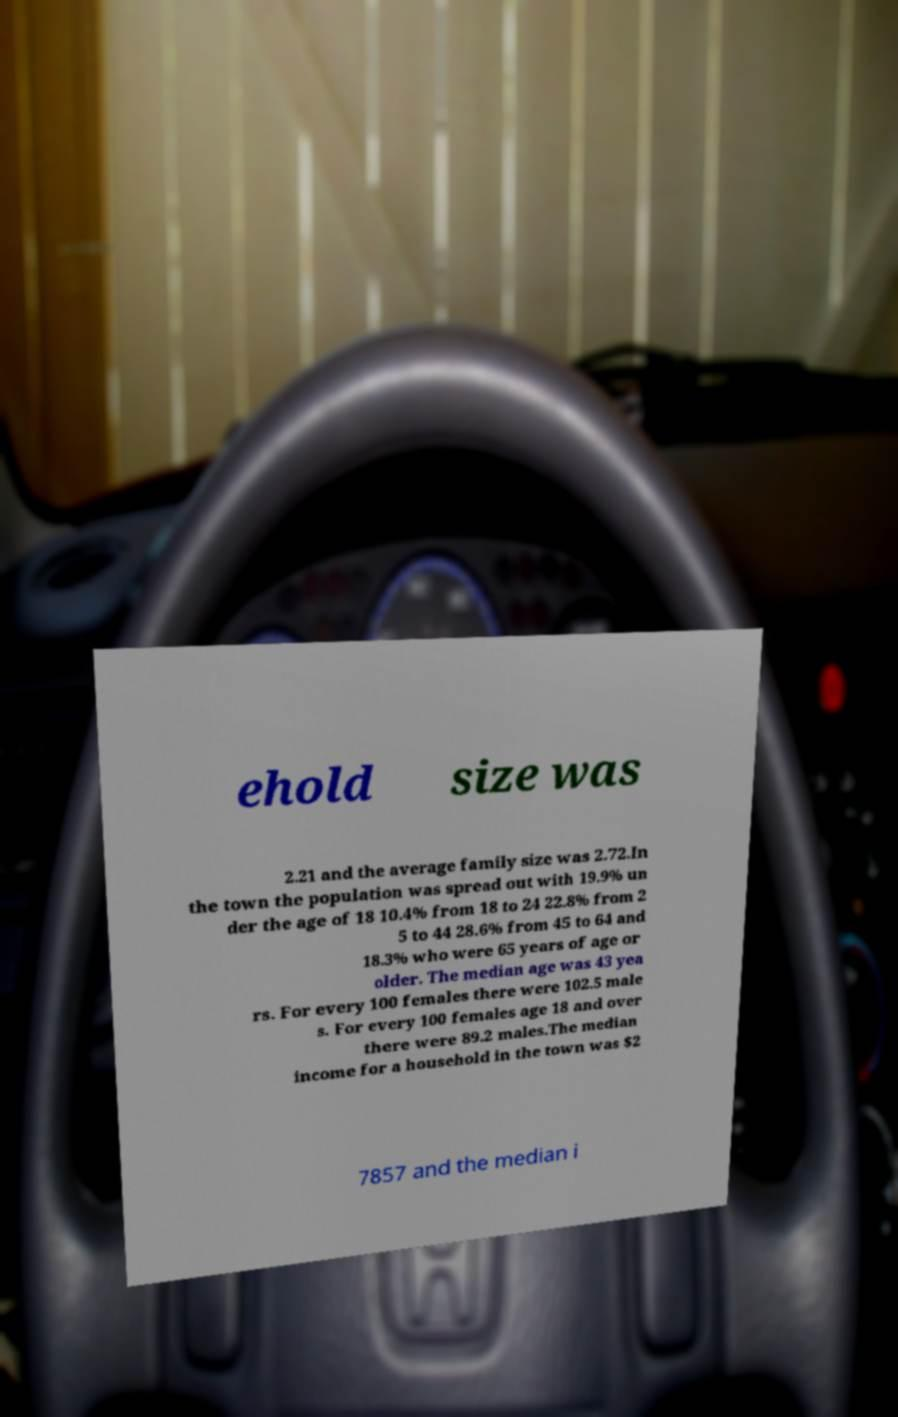What messages or text are displayed in this image? I need them in a readable, typed format. ehold size was 2.21 and the average family size was 2.72.In the town the population was spread out with 19.9% un der the age of 18 10.4% from 18 to 24 22.8% from 2 5 to 44 28.6% from 45 to 64 and 18.3% who were 65 years of age or older. The median age was 43 yea rs. For every 100 females there were 102.5 male s. For every 100 females age 18 and over there were 89.2 males.The median income for a household in the town was $2 7857 and the median i 